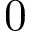<formula> <loc_0><loc_0><loc_500><loc_500>0</formula> 